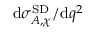Convert formula to latex. <formula><loc_0><loc_0><loc_500><loc_500>d \sigma _ { A , \chi } ^ { S D } / d q ^ { 2 }</formula> 